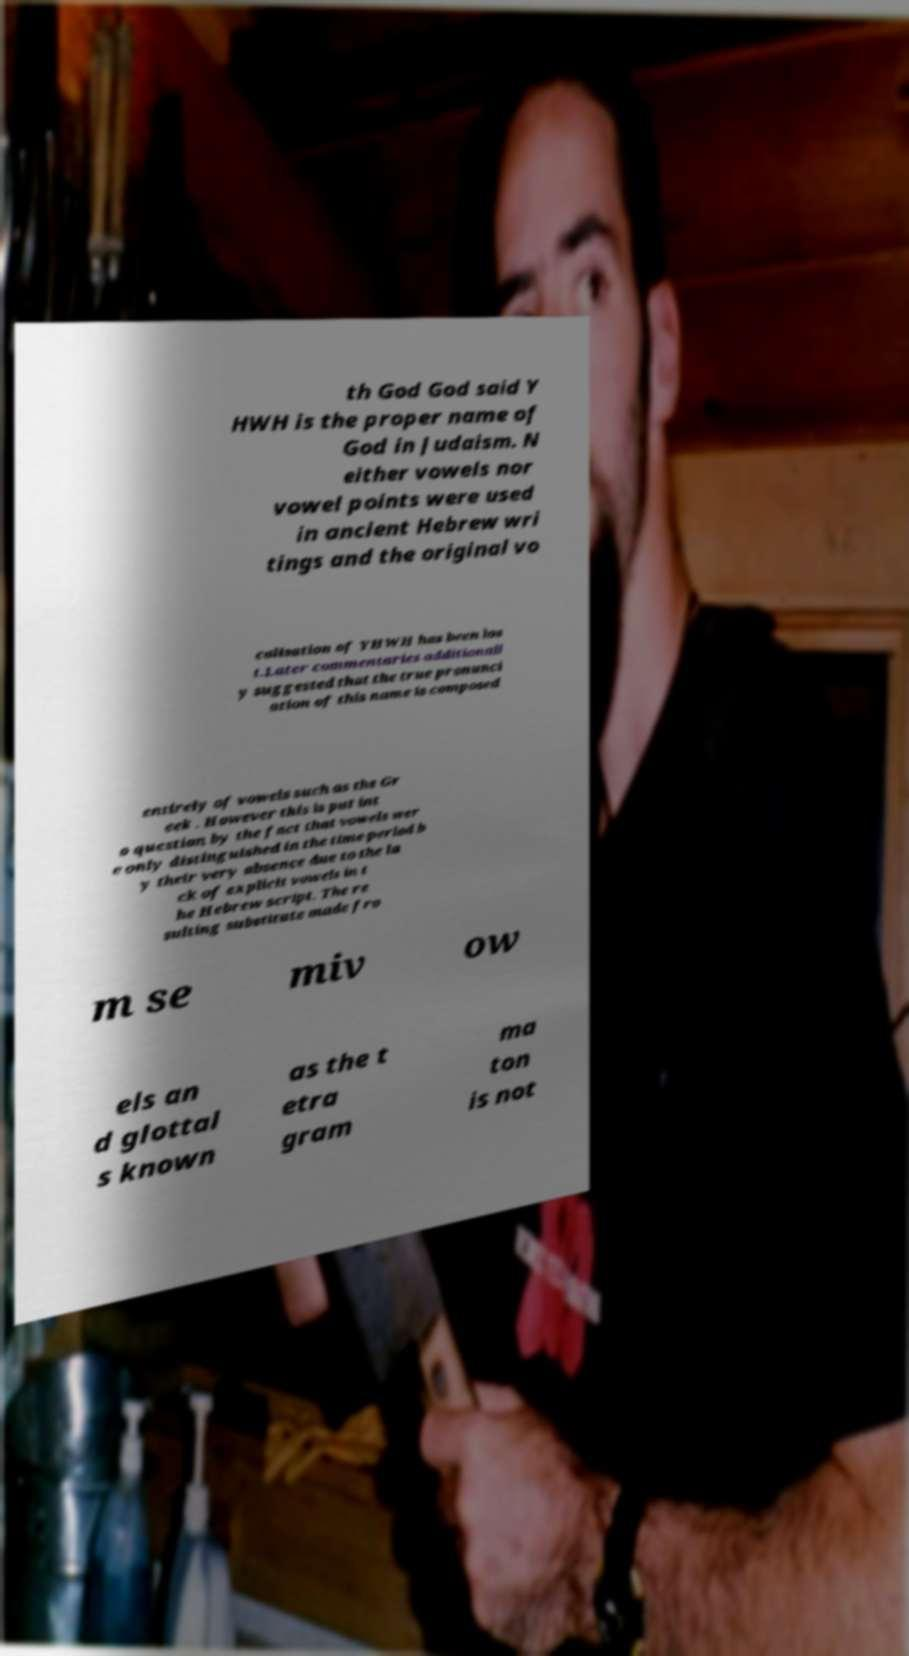There's text embedded in this image that I need extracted. Can you transcribe it verbatim? th God God said Y HWH is the proper name of God in Judaism. N either vowels nor vowel points were used in ancient Hebrew wri tings and the original vo calisation of YHWH has been los t.Later commentaries additionall y suggested that the true pronunci ation of this name is composed entirely of vowels such as the Gr eek . However this is put int o question by the fact that vowels wer e only distinguished in the time-period b y their very absence due to the la ck of explicit vowels in t he Hebrew script. The re sulting substitute made fro m se miv ow els an d glottal s known as the t etra gram ma ton is not 